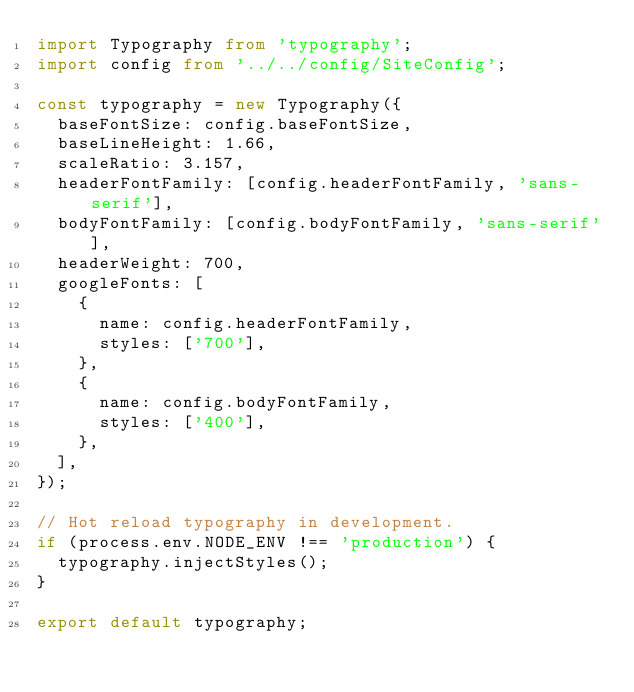Convert code to text. <code><loc_0><loc_0><loc_500><loc_500><_TypeScript_>import Typography from 'typography';
import config from '../../config/SiteConfig';

const typography = new Typography({
  baseFontSize: config.baseFontSize,
  baseLineHeight: 1.66,
  scaleRatio: 3.157,
  headerFontFamily: [config.headerFontFamily, 'sans-serif'],
  bodyFontFamily: [config.bodyFontFamily, 'sans-serif'],
  headerWeight: 700,
  googleFonts: [
    {
      name: config.headerFontFamily,
      styles: ['700'],
    },
    {
      name: config.bodyFontFamily,
      styles: ['400'],
    },
  ],
});

// Hot reload typography in development.
if (process.env.NODE_ENV !== 'production') {
  typography.injectStyles();
}

export default typography;
</code> 